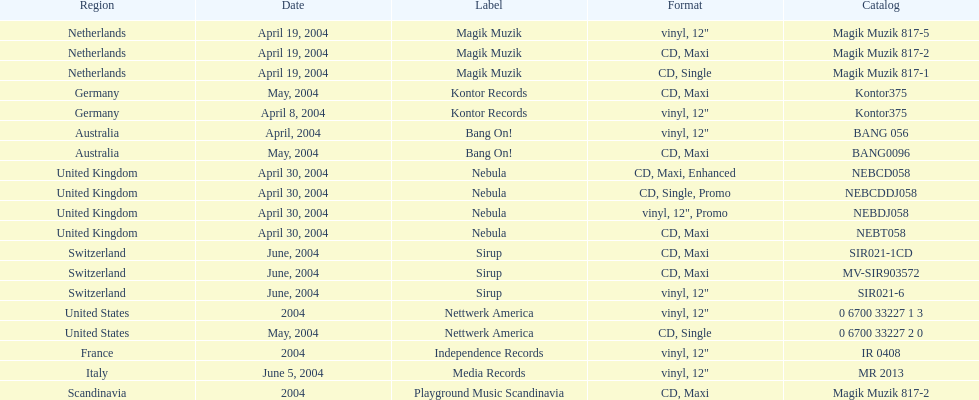What label was used by the netherlands in love comes again? Magik Muzik. What label was used in germany? Kontor Records. What label was used in france? Independence Records. 